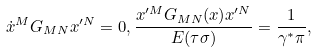Convert formula to latex. <formula><loc_0><loc_0><loc_500><loc_500>\dot { x } ^ { M } G _ { M N } x ^ { \prime N } = 0 , { \frac { x ^ { \prime M } G _ { M N } ( x ) x ^ { \prime N } } { E ( \tau \sigma ) } } = { \frac { 1 } { \gamma ^ { \ast } \pi } } ,</formula> 